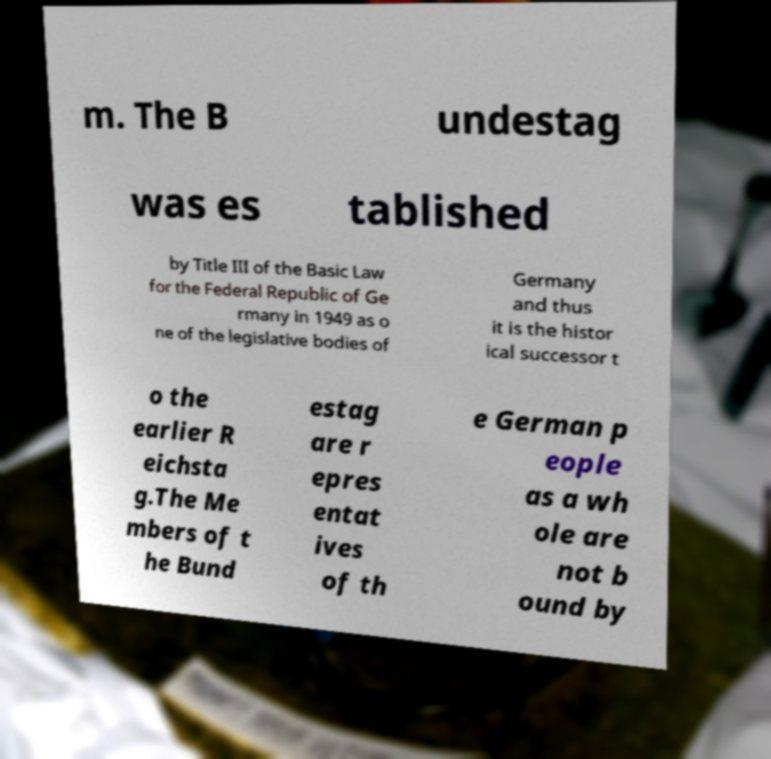Please identify and transcribe the text found in this image. m. The B undestag was es tablished by Title III of the Basic Law for the Federal Republic of Ge rmany in 1949 as o ne of the legislative bodies of Germany and thus it is the histor ical successor t o the earlier R eichsta g.The Me mbers of t he Bund estag are r epres entat ives of th e German p eople as a wh ole are not b ound by 